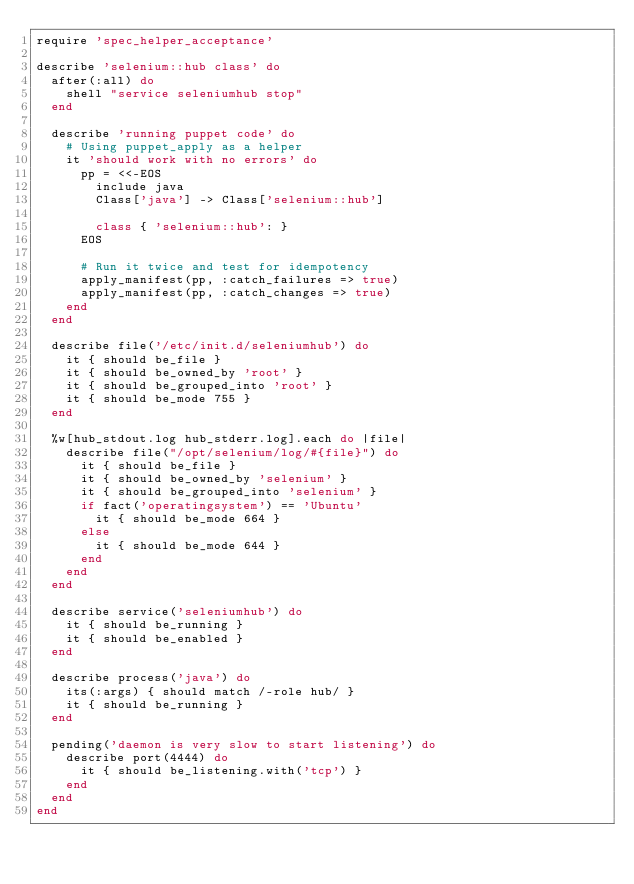<code> <loc_0><loc_0><loc_500><loc_500><_Ruby_>require 'spec_helper_acceptance'

describe 'selenium::hub class' do
  after(:all) do
    shell "service seleniumhub stop"
  end

  describe 'running puppet code' do
    # Using puppet_apply as a helper
    it 'should work with no errors' do
      pp = <<-EOS
        include java
        Class['java'] -> Class['selenium::hub']

        class { 'selenium::hub': }
      EOS

      # Run it twice and test for idempotency
      apply_manifest(pp, :catch_failures => true)
      apply_manifest(pp, :catch_changes => true)
    end
  end

  describe file('/etc/init.d/seleniumhub') do
    it { should be_file }
    it { should be_owned_by 'root' }
    it { should be_grouped_into 'root' }
    it { should be_mode 755 }
  end

  %w[hub_stdout.log hub_stderr.log].each do |file|
    describe file("/opt/selenium/log/#{file}") do
      it { should be_file }
      it { should be_owned_by 'selenium' }
      it { should be_grouped_into 'selenium' }
      if fact('operatingsystem') == 'Ubuntu'
        it { should be_mode 664 }
      else
        it { should be_mode 644 }
      end
    end
  end

  describe service('seleniumhub') do
    it { should be_running }
    it { should be_enabled }
  end

  describe process('java') do
    its(:args) { should match /-role hub/ }
    it { should be_running }
  end

  pending('daemon is very slow to start listening') do
    describe port(4444) do
      it { should be_listening.with('tcp') }
    end
  end
end
</code> 